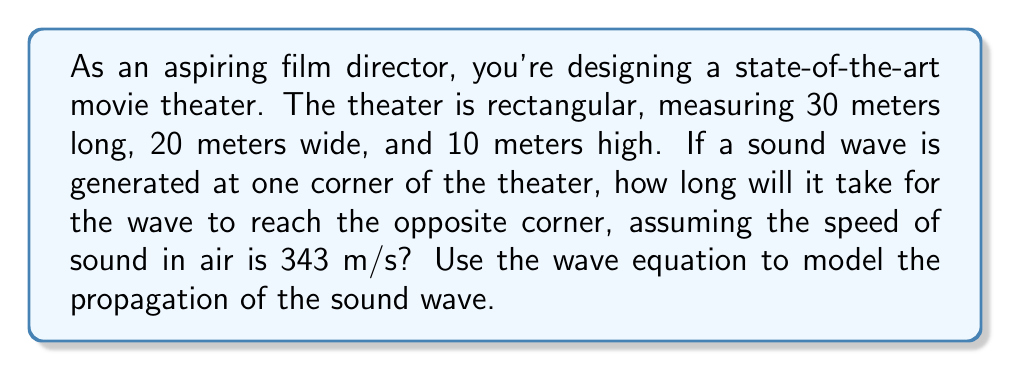Provide a solution to this math problem. Let's approach this step-by-step:

1) The wave equation in three dimensions is:

   $$\frac{\partial^2 u}{\partial t^2} = c^2 \left(\frac{\partial^2 u}{\partial x^2} + \frac{\partial^2 u}{\partial y^2} + \frac{\partial^2 u}{\partial z^2}\right)$$

   where $c$ is the speed of sound.

2) However, we don't need to solve the wave equation directly. We can use the fact that sound waves travel in straight lines in a uniform medium.

3) The sound wave will travel along the diagonal of the rectangular prism (theater).

4) We can calculate the length of this diagonal using the 3D extension of the Pythagorean theorem:

   $$d = \sqrt{x^2 + y^2 + z^2}$$

   where $d$ is the diagonal, and $x$, $y$, and $z$ are the dimensions of the theater.

5) Plugging in the values:

   $$d = \sqrt{30^2 + 20^2 + 10^2} = \sqrt{900 + 400 + 100} = \sqrt{1400} \approx 37.42 \text{ meters}$$

6) Now that we know the distance, we can use the simple equation:

   $$\text{time} = \frac{\text{distance}}{\text{speed}}$$

7) Plugging in our values:

   $$\text{time} = \frac{37.42 \text{ m}}{343 \text{ m/s}} \approx 0.1091 \text{ seconds}$$

Thus, it will take approximately 0.1091 seconds for the sound wave to reach the opposite corner.
Answer: 0.1091 seconds 